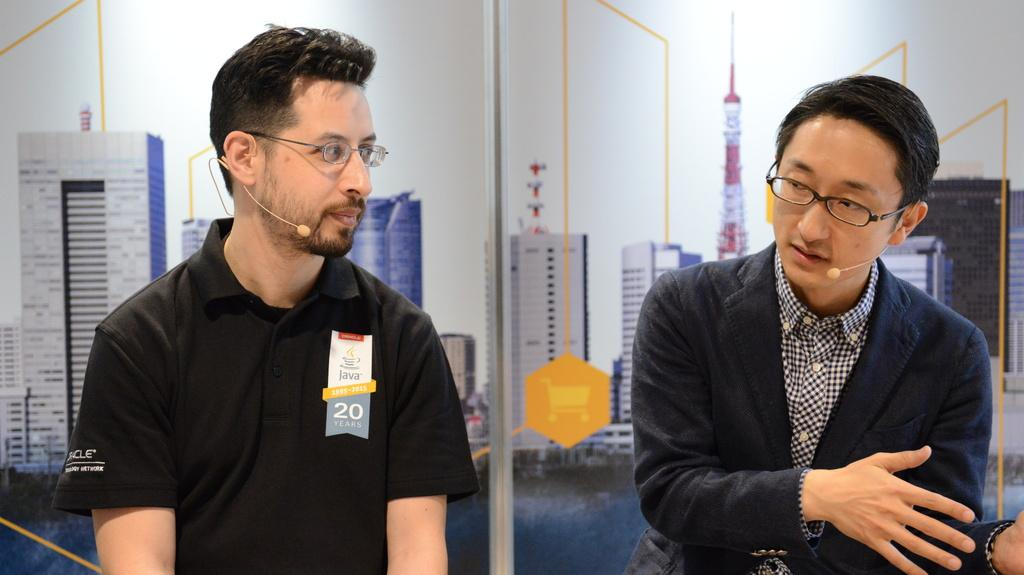How many people are in the image? There are two people in the image. What is one person wearing? One person is wearing a suit. What can be seen in the background of the image? There are posters visible in the background. How many cracks can be seen on the person wearing the suit in the image? There are no cracks visible on the person wearing the suit in the image. What type of clam is being held by the person not wearing the suit in the image? There is no clam present in the image; both individuals are standing without any visible objects. 